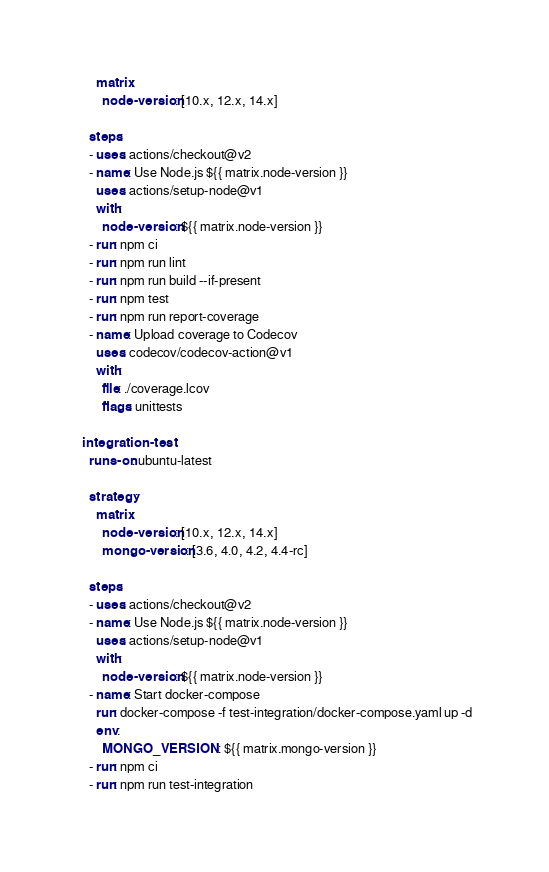Convert code to text. <code><loc_0><loc_0><loc_500><loc_500><_YAML_>      matrix:
        node-version: [10.x, 12.x, 14.x]

    steps:
    - uses: actions/checkout@v2
    - name: Use Node.js ${{ matrix.node-version }}
      uses: actions/setup-node@v1
      with:
        node-version: ${{ matrix.node-version }}
    - run: npm ci
    - run: npm run lint
    - run: npm run build --if-present
    - run: npm test
    - run: npm run report-coverage
    - name: Upload coverage to Codecov
      uses: codecov/codecov-action@v1
      with:
        file: ./coverage.lcov
        flags: unittests

  integration-test:
    runs-on: ubuntu-latest

    strategy:
      matrix:
        node-version: [10.x, 12.x, 14.x]
        mongo-version: [3.6, 4.0, 4.2, 4.4-rc]

    steps:
    - uses: actions/checkout@v2
    - name: Use Node.js ${{ matrix.node-version }}
      uses: actions/setup-node@v1
      with:
        node-version: ${{ matrix.node-version }}
    - name: Start docker-compose
      run: docker-compose -f test-integration/docker-compose.yaml up -d
      env:
        MONGO_VERSION: ${{ matrix.mongo-version }}
    - run: npm ci
    - run: npm run test-integration

</code> 